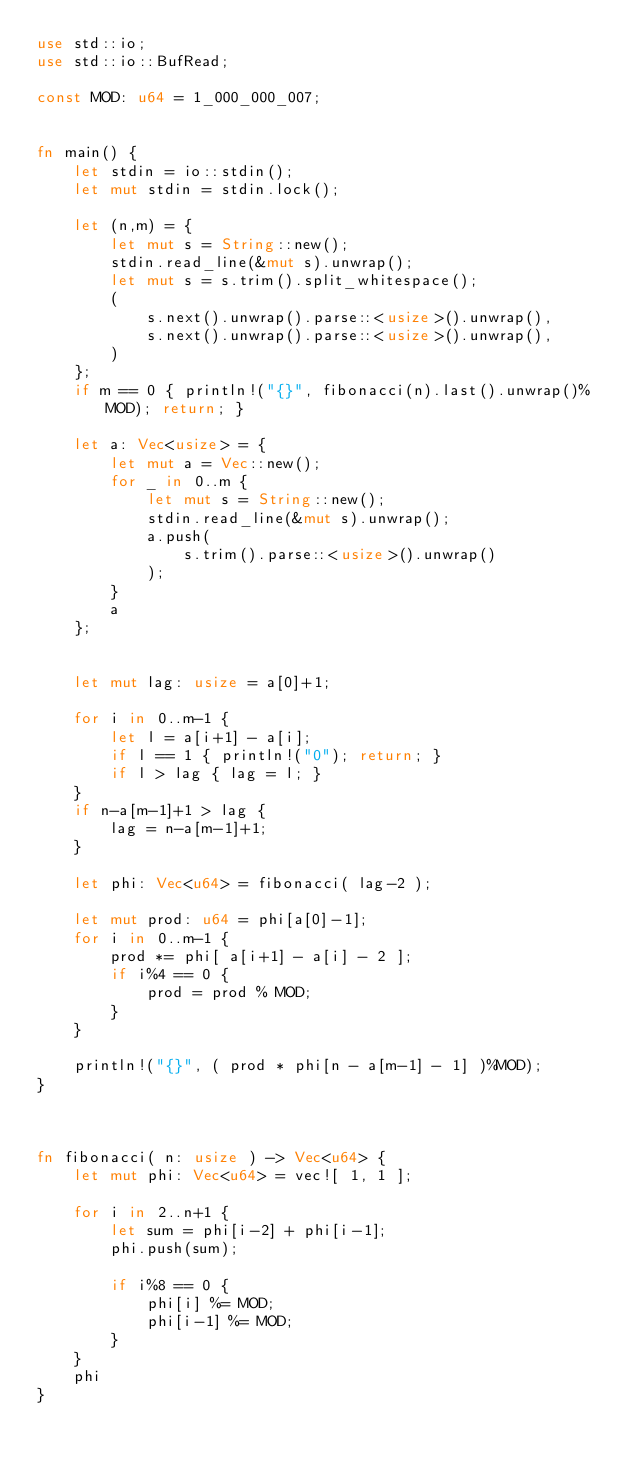<code> <loc_0><loc_0><loc_500><loc_500><_Rust_>use std::io;
use std::io::BufRead;

const MOD: u64 = 1_000_000_007;


fn main() {
    let stdin = io::stdin();
    let mut stdin = stdin.lock();
    
    let (n,m) = {
        let mut s = String::new();
        stdin.read_line(&mut s).unwrap();
        let mut s = s.trim().split_whitespace();
        (
            s.next().unwrap().parse::<usize>().unwrap(),
            s.next().unwrap().parse::<usize>().unwrap(),
        )
    };
    if m == 0 { println!("{}", fibonacci(n).last().unwrap()%MOD); return; }

    let a: Vec<usize> = {
        let mut a = Vec::new();
        for _ in 0..m {
            let mut s = String::new();
            stdin.read_line(&mut s).unwrap();
            a.push(
                s.trim().parse::<usize>().unwrap()
            );
        }
        a
    };


    let mut lag: usize = a[0]+1;
    
    for i in 0..m-1 {
        let l = a[i+1] - a[i];
        if l == 1 { println!("0"); return; }
        if l > lag { lag = l; }
    }
    if n-a[m-1]+1 > lag {
        lag = n-a[m-1]+1;
    }

    let phi: Vec<u64> = fibonacci( lag-2 );

    let mut prod: u64 = phi[a[0]-1];
    for i in 0..m-1 {
        prod *= phi[ a[i+1] - a[i] - 2 ];
        if i%4 == 0 {
            prod = prod % MOD;
        }
    }

    println!("{}", ( prod * phi[n - a[m-1] - 1] )%MOD);
}



fn fibonacci( n: usize ) -> Vec<u64> {
    let mut phi: Vec<u64> = vec![ 1, 1 ];

    for i in 2..n+1 {
        let sum = phi[i-2] + phi[i-1];
        phi.push(sum);

        if i%8 == 0 {
            phi[i] %= MOD;
            phi[i-1] %= MOD;
        }
    }
    phi
}
</code> 